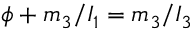Convert formula to latex. <formula><loc_0><loc_0><loc_500><loc_500>\phi + m _ { 3 } / I _ { 1 } = m _ { 3 } / I _ { 3 }</formula> 